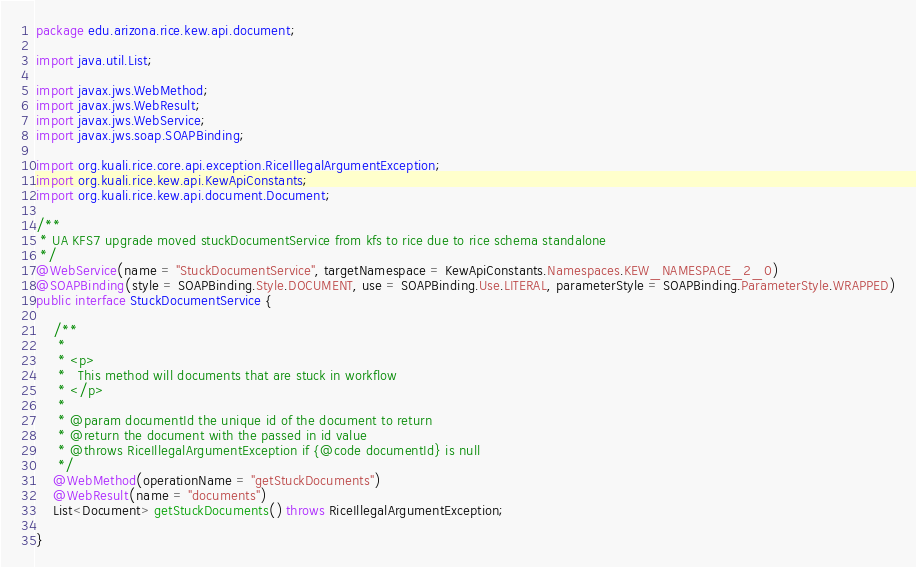Convert code to text. <code><loc_0><loc_0><loc_500><loc_500><_Java_>package edu.arizona.rice.kew.api.document;

import java.util.List;

import javax.jws.WebMethod;
import javax.jws.WebResult;
import javax.jws.WebService;
import javax.jws.soap.SOAPBinding;

import org.kuali.rice.core.api.exception.RiceIllegalArgumentException;
import org.kuali.rice.kew.api.KewApiConstants;
import org.kuali.rice.kew.api.document.Document;

/**
 * UA KFS7 upgrade moved stuckDocumentService from kfs to rice due to rice schema standalone
 */
@WebService(name = "StuckDocumentService", targetNamespace = KewApiConstants.Namespaces.KEW_NAMESPACE_2_0)
@SOAPBinding(style = SOAPBinding.Style.DOCUMENT, use = SOAPBinding.Use.LITERAL, parameterStyle = SOAPBinding.ParameterStyle.WRAPPED)
public interface StuckDocumentService {

    /**
     *
     * <p>
     *   This method will documents that are stuck in workflow
     * </p>
     *
     * @param documentId the unique id of the document to return
     * @return the document with the passed in id value
     * @throws RiceIllegalArgumentException if {@code documentId} is null
     */
    @WebMethod(operationName = "getStuckDocuments")
    @WebResult(name = "documents")
    List<Document> getStuckDocuments() throws RiceIllegalArgumentException;

}
</code> 